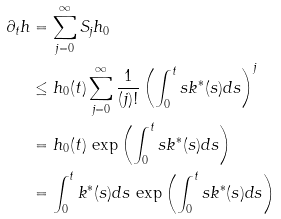<formula> <loc_0><loc_0><loc_500><loc_500>\partial _ { t } h & = \sum _ { j = 0 } ^ { \infty } S _ { j } h _ { 0 } \\ & \leq h _ { 0 } ( t ) \sum _ { j = 0 } ^ { \infty } \frac { 1 } { ( j ) ! } \left ( \int _ { 0 } ^ { t } s k ^ { * } ( s ) d s \right ) ^ { j } \\ & = h _ { 0 } ( t ) \, \exp \left ( \int _ { 0 } ^ { t } s k ^ { * } ( s ) d s \right ) \\ & = \int _ { 0 } ^ { t } k ^ { * } ( s ) d s \, \exp \left ( \int _ { 0 } ^ { t } s k ^ { * } ( s ) d s \right )</formula> 